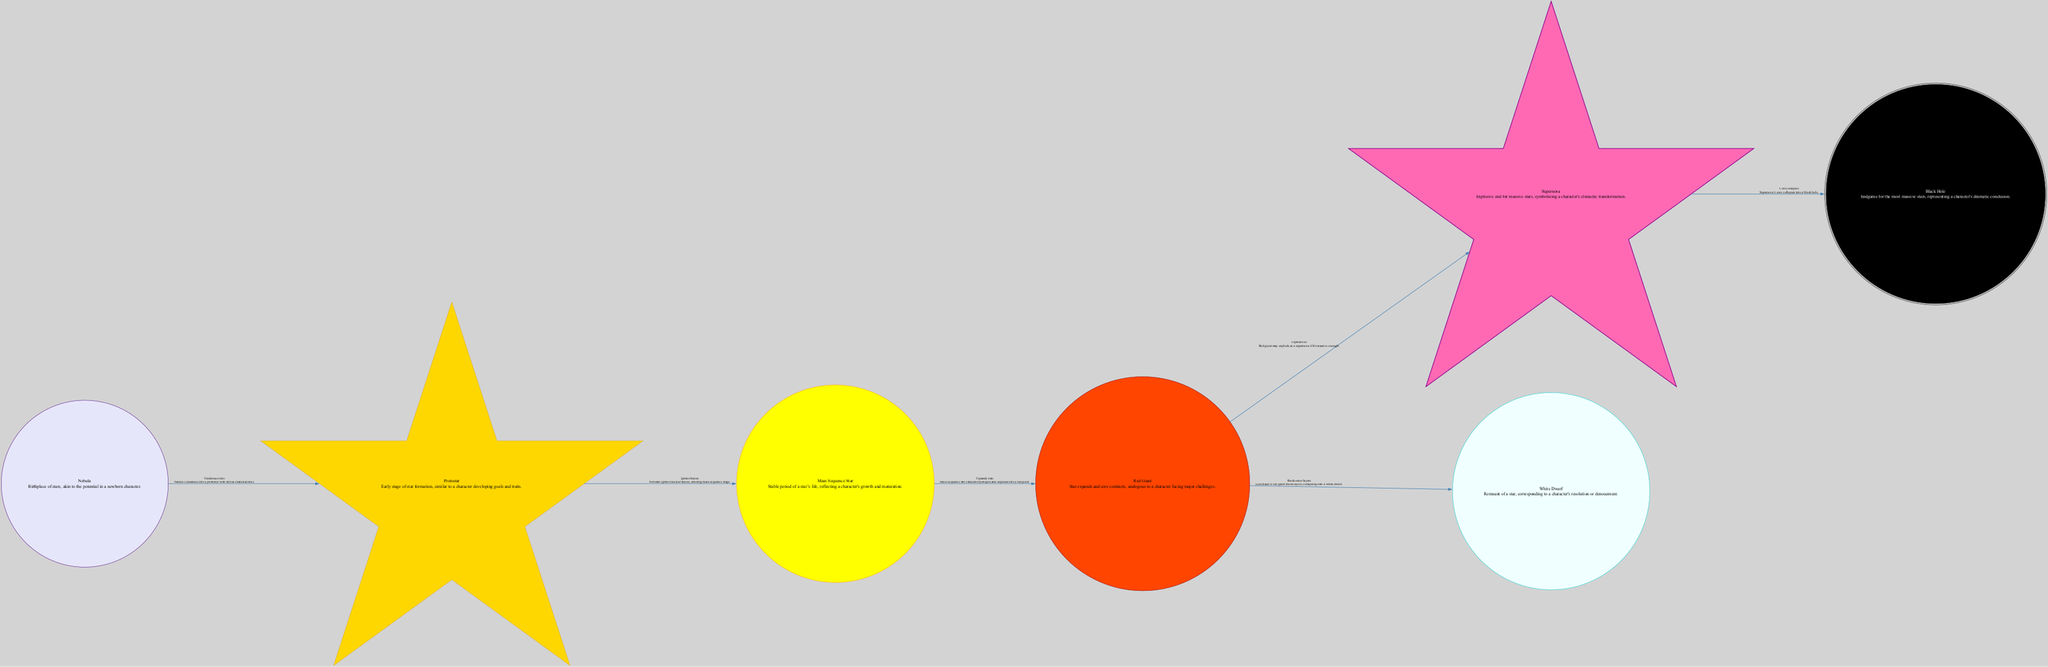What is the starting point of the star life cycle in this diagram? The starting point is the "Nebula," which is indicated as the first node in the diagram. It serves as the birthplace of stars, representing the potential in a newborn character.
Answer: Nebula How many nodes are present in the diagram? By counting each individual stage of the star life cycle listed in the nodes section, we find there are seven distinct nodes: Nebula, Protostar, Main Sequence Star, Red Giant, Supernova, White Dwarf, and Black Hole.
Answer: Seven What relationship is indicated between the "Red Giant" and "Supernova"? The diagram specifies a relationship where the "Red Giant" can explode as a "Supernova" if it is massive enough. This is one of the critical transitions in the life cycle of a star depicted within the diagram.
Answer: Explodes as Which node corresponds to a character's resolution or denouement? The "White Dwarf" represents the resolution of a star, similar to how a character resolves their story arc. This is explicitly described in the diagram's description for this node.
Answer: White Dwarf What happens to a "Supernova" after its core collapses? According to the diagram, after the "Supernova," its core collapses into a "Black Hole." This relationship marks the final stage for the most massive stars in the life cycle presented.
Answer: Black Hole What transformation does a star undergo when it moves from "Main Sequence" to "Red Giant"? The transition involves the star exhausting its hydrogen and subsequently expanding into a "Red Giant." This transformation reflects significant changes in the star's state during its life cycle.
Answer: Expands into How does the "Protostar" stage relate to character development in literature? The "Protostar" is likened to a character developing goals and traits, illustrated by the description that links this crucial early stage of star formation to character growth in narratives.
Answer: Developing goals and traits What is the final fate of a massive star according to the diagram? The final fate of the most massive stars is represented as becoming a "Black Hole" following a supernova event, indicating the ultimate transformation in the star's life cycle.
Answer: Black Hole 